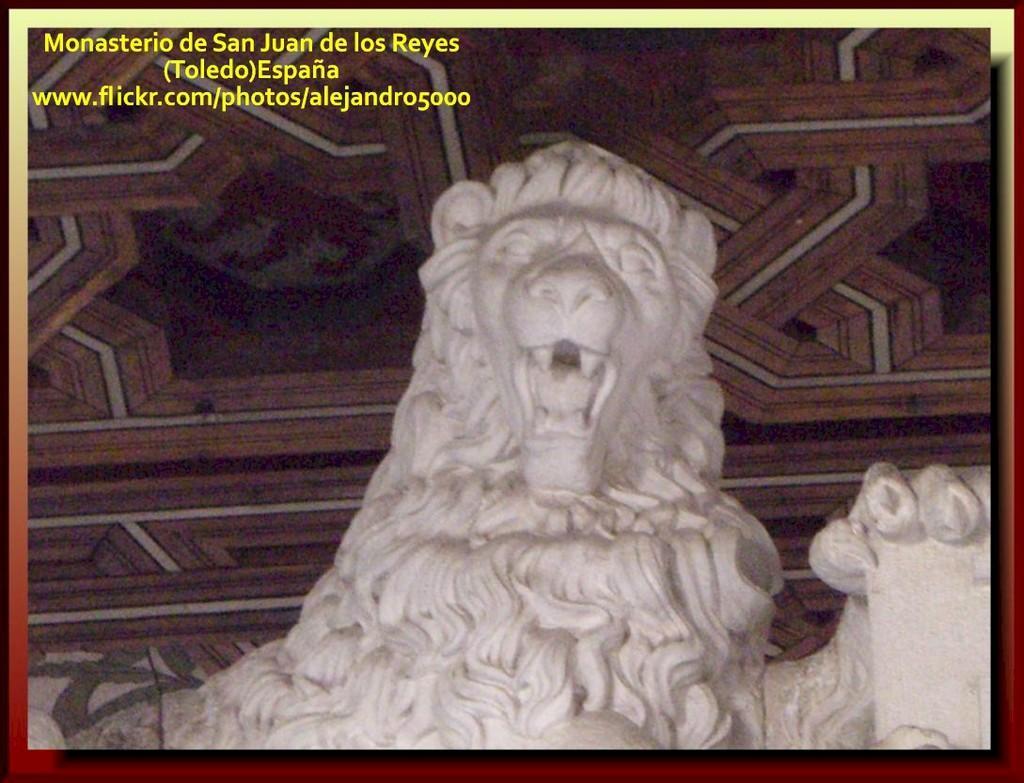Can you describe this image briefly? In this image I can see a statue of a lion which is white in color. In the background I can see the surface which is brown, black and white in color. 